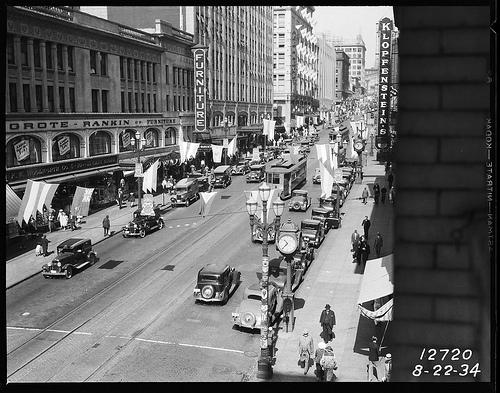What country was this photo taken?
Answer briefly. Usa. Is there a palm tree?
Write a very short answer. No. Is this a two-way street?
Short answer required. Yes. Is this picture going to rust and change?
Concise answer only. No. Was this picture taken on Wall Street?
Answer briefly. No. Is this a recent photo?
Write a very short answer. No. Are there people in the picture?
Short answer required. Yes. 